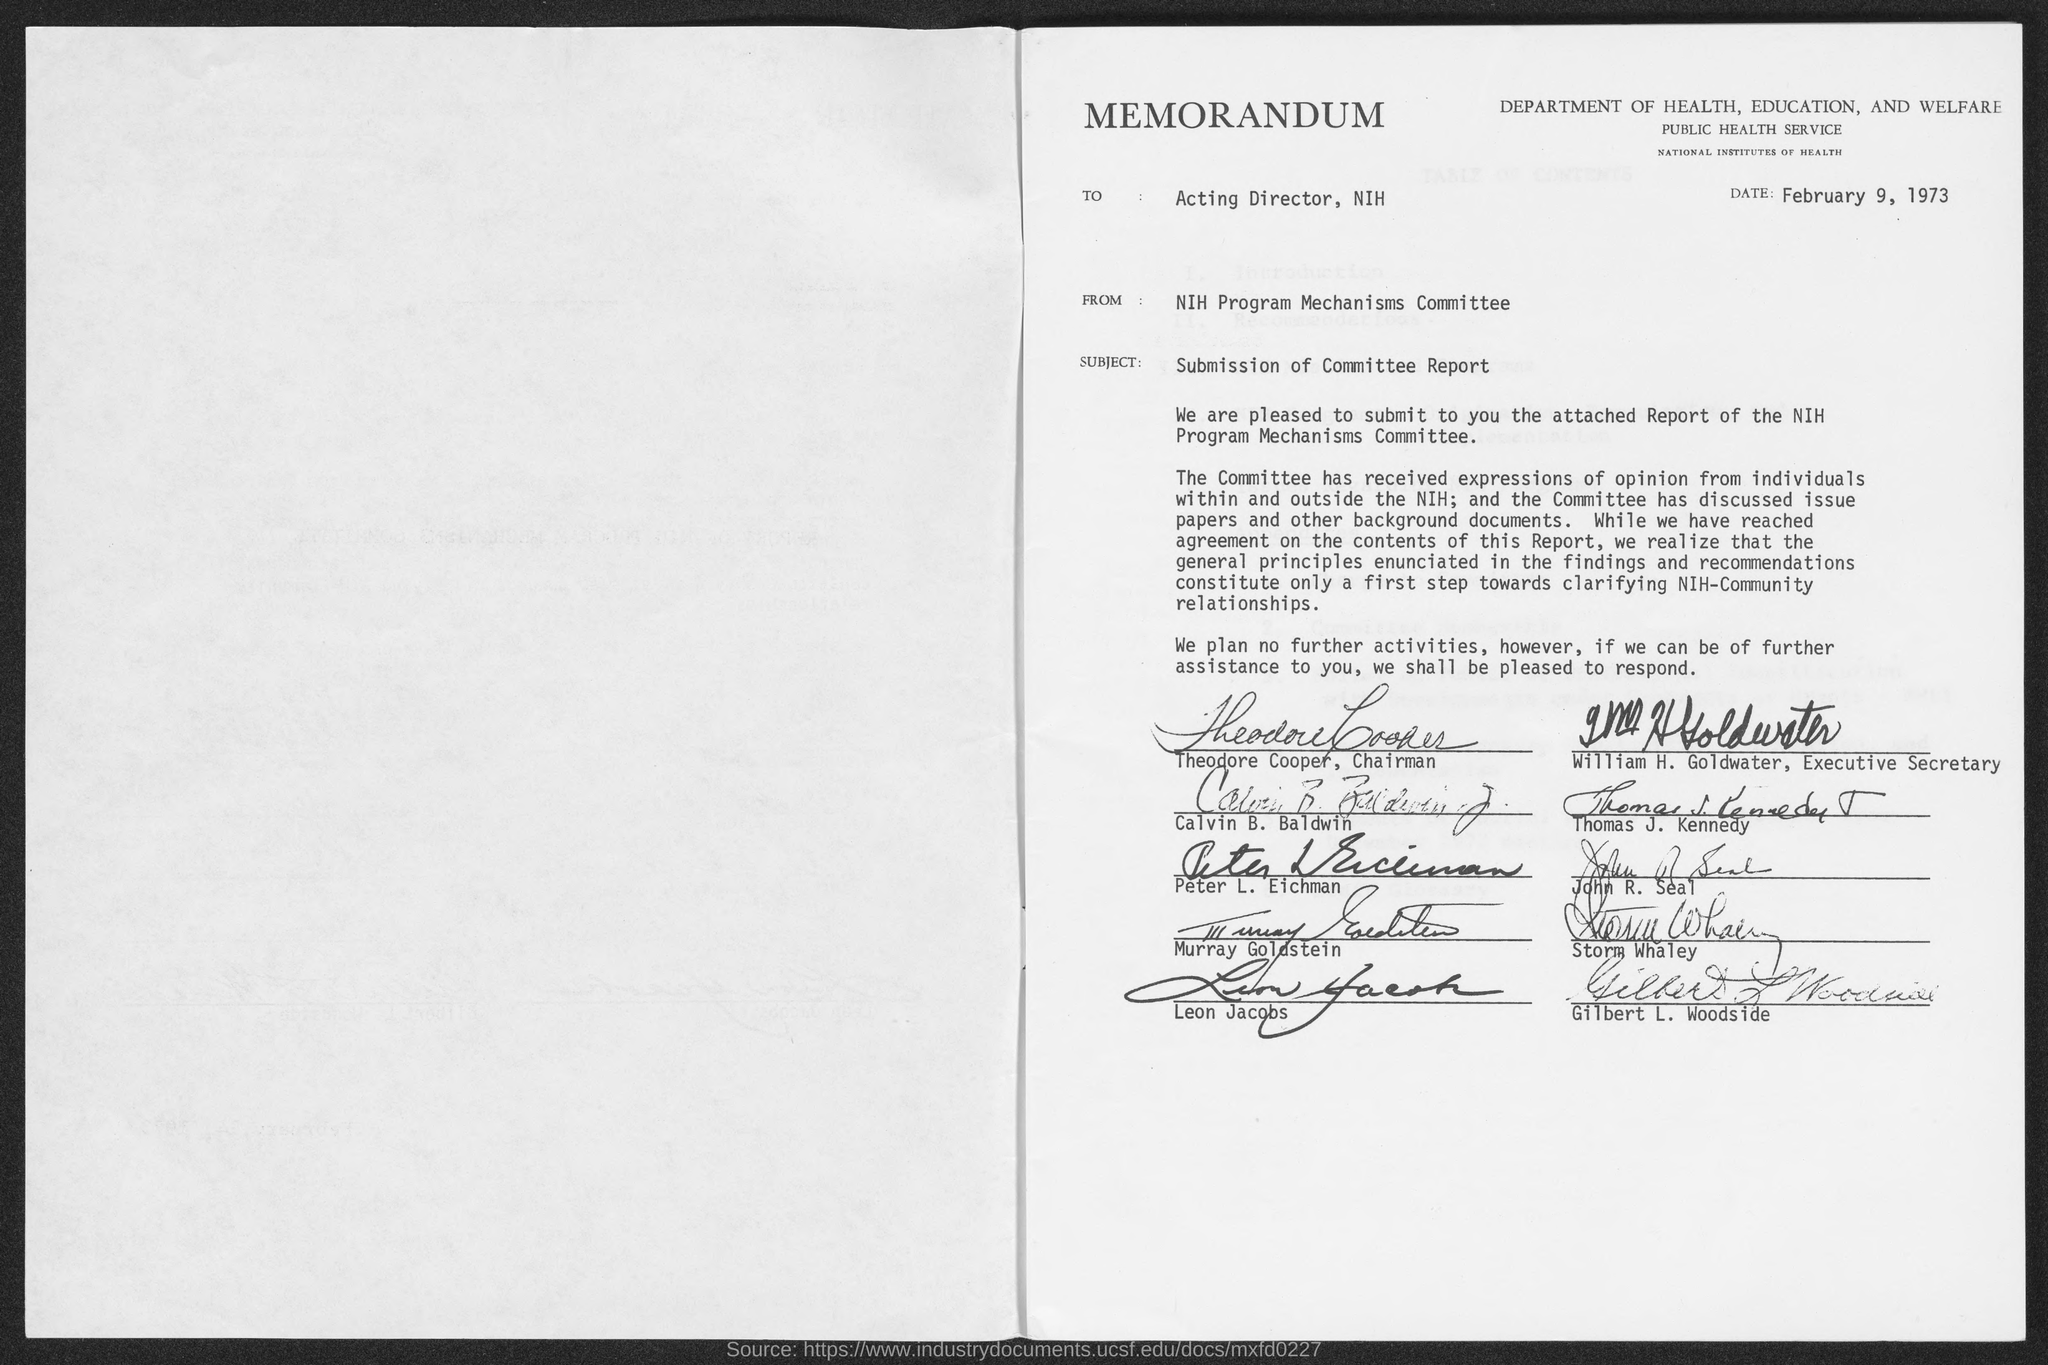When is the memorandum dated?
Offer a terse response. February 9, 1973. What is the subject of memorandum ?
Your response must be concise. Submission of committee report. What is the from address of memorandum ?
Your answer should be very brief. Nih program mechanisms committee. Who is the chairman, department of health, education and welfare?
Provide a succinct answer. Theodore cooper. Who is the executive secretary, department of health, education and welfare?
Offer a very short reply. William H. Goldwater. 